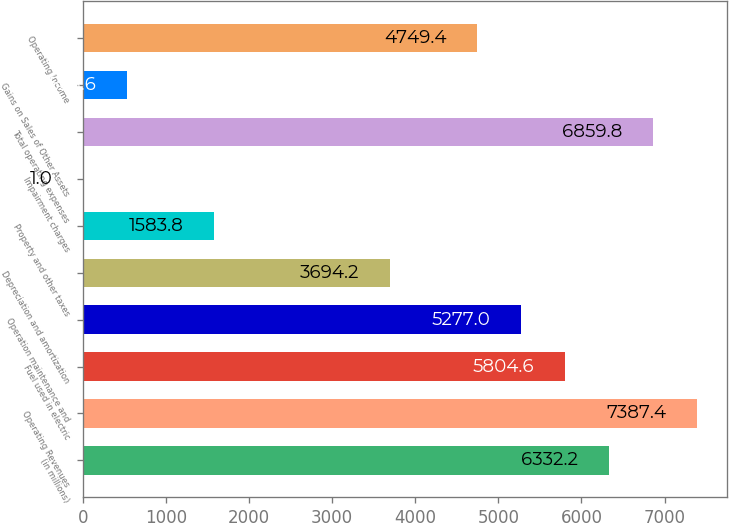<chart> <loc_0><loc_0><loc_500><loc_500><bar_chart><fcel>(in millions)<fcel>Operating Revenues<fcel>Fuel used in electric<fcel>Operation maintenance and<fcel>Depreciation and amortization<fcel>Property and other taxes<fcel>Impairment charges<fcel>Total operating expenses<fcel>Gains on Sales of Other Assets<fcel>Operating Income<nl><fcel>6332.2<fcel>7387.4<fcel>5804.6<fcel>5277<fcel>3694.2<fcel>1583.8<fcel>1<fcel>6859.8<fcel>528.6<fcel>4749.4<nl></chart> 